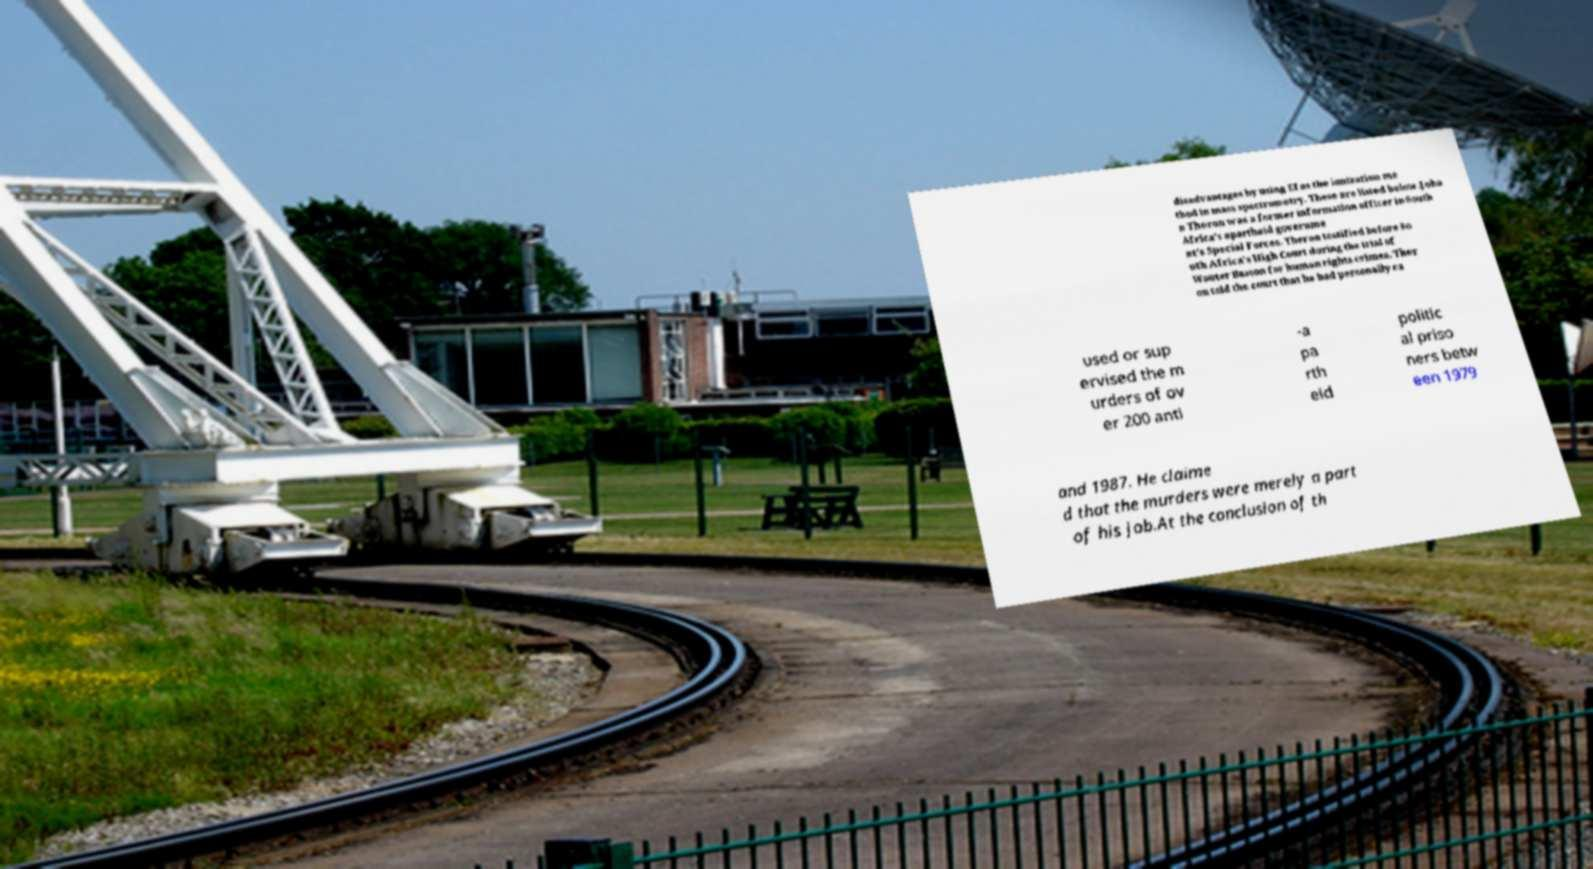For documentation purposes, I need the text within this image transcribed. Could you provide that? disadvantages by using EI as the ionization me thod in mass spectrometry. These are listed below.Joha n Theron was a former information officer in South Africa's apartheid governme nt's Special Forces. Theron testified before So uth Africa's High Court during the trial of Wouter Basson for human rights crimes. Ther on told the court that he had personally ca used or sup ervised the m urders of ov er 200 anti -a pa rth eid politic al priso ners betw een 1979 and 1987. He claime d that the murders were merely a part of his job.At the conclusion of th 